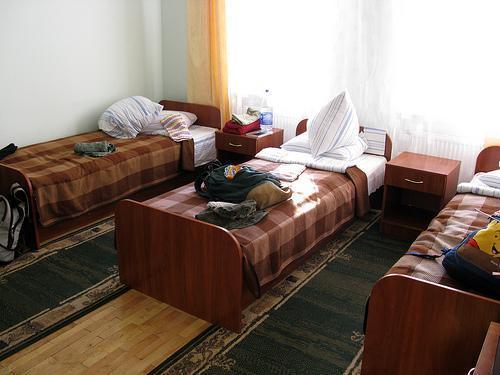How many beds are in the photo?
Give a very brief answer. 3. How many pillows are on each bed?
Give a very brief answer. 2. How many people can sleep on each bed?
Give a very brief answer. 1. 